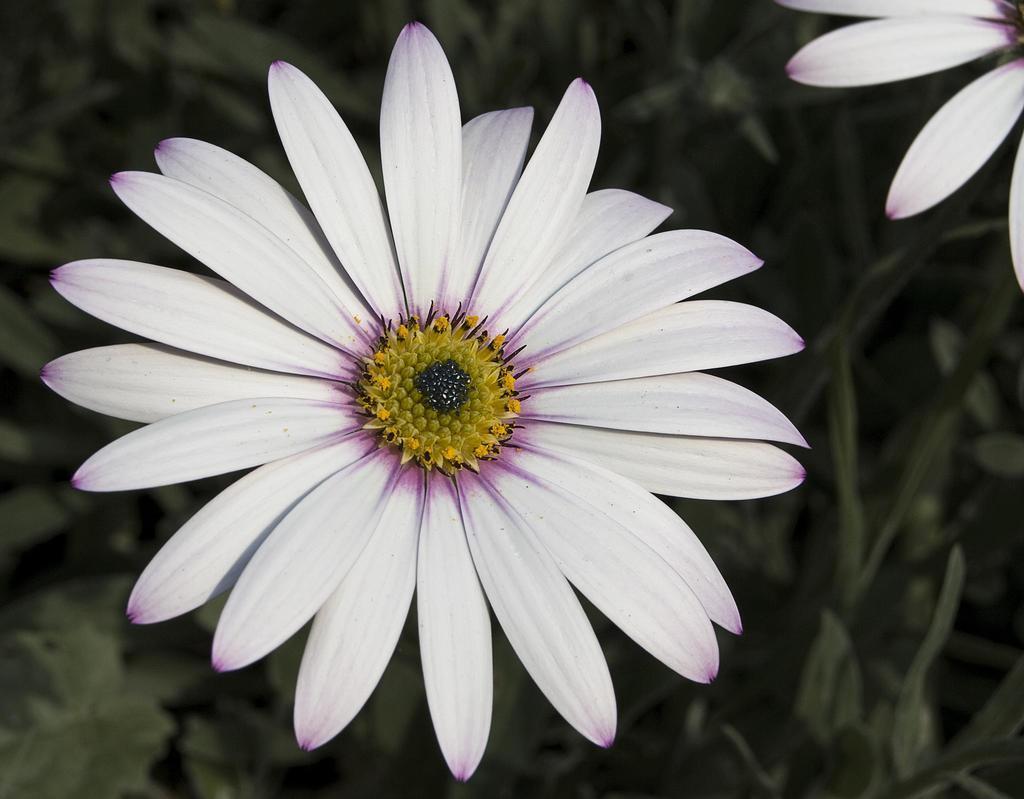Can you describe this image briefly? In this image there are flowers, at the background of the image there are plants. 